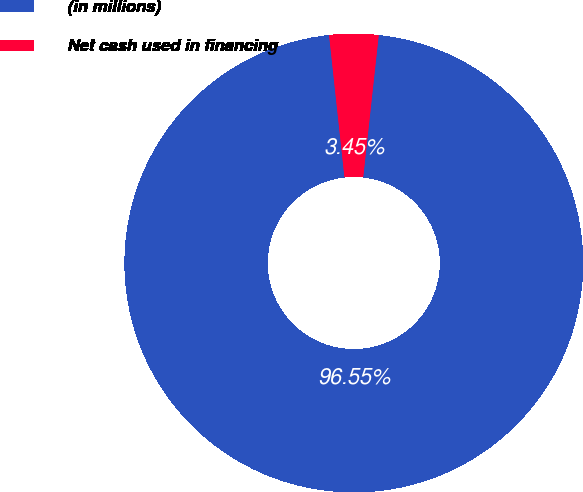Convert chart to OTSL. <chart><loc_0><loc_0><loc_500><loc_500><pie_chart><fcel>(in millions)<fcel>Net cash used in financing<nl><fcel>96.55%<fcel>3.45%<nl></chart> 